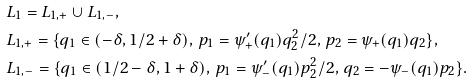<formula> <loc_0><loc_0><loc_500><loc_500>& L _ { 1 } = L _ { 1 , + } \cup L _ { 1 , - } , \\ & L _ { 1 , + } = \{ q _ { 1 } \in ( - \delta , 1 / 2 + \delta ) , \, p _ { 1 } = \psi ^ { \prime } _ { + } ( q _ { 1 } ) q _ { 2 } ^ { 2 } / 2 , \, p _ { 2 } = \psi _ { + } ( q _ { 1 } ) q _ { 2 } \} , \\ & L _ { 1 , - } = \{ q _ { 1 } \in ( 1 / 2 - \delta , 1 + \delta ) , \, p _ { 1 } = \psi ^ { \prime } _ { - } ( q _ { 1 } ) p _ { 2 } ^ { 2 } / 2 , \, q _ { 2 } = - \psi _ { - } ( q _ { 1 } ) p _ { 2 } \} .</formula> 